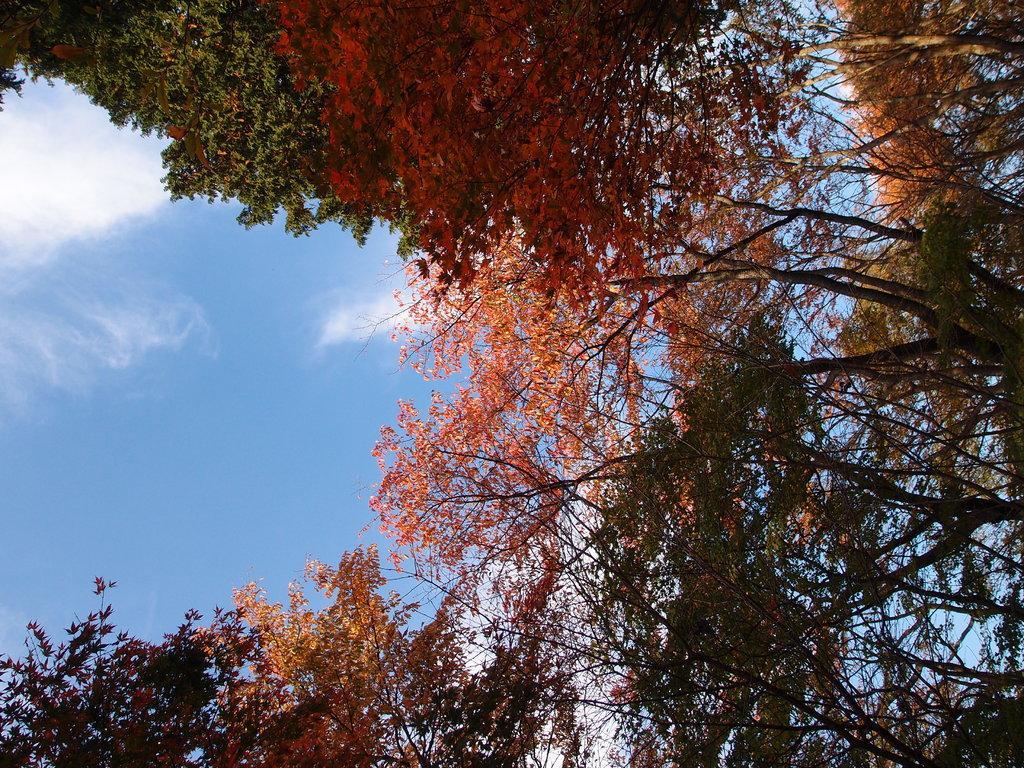In one or two sentences, can you explain what this image depicts? We can see trees and sky with clouds. 